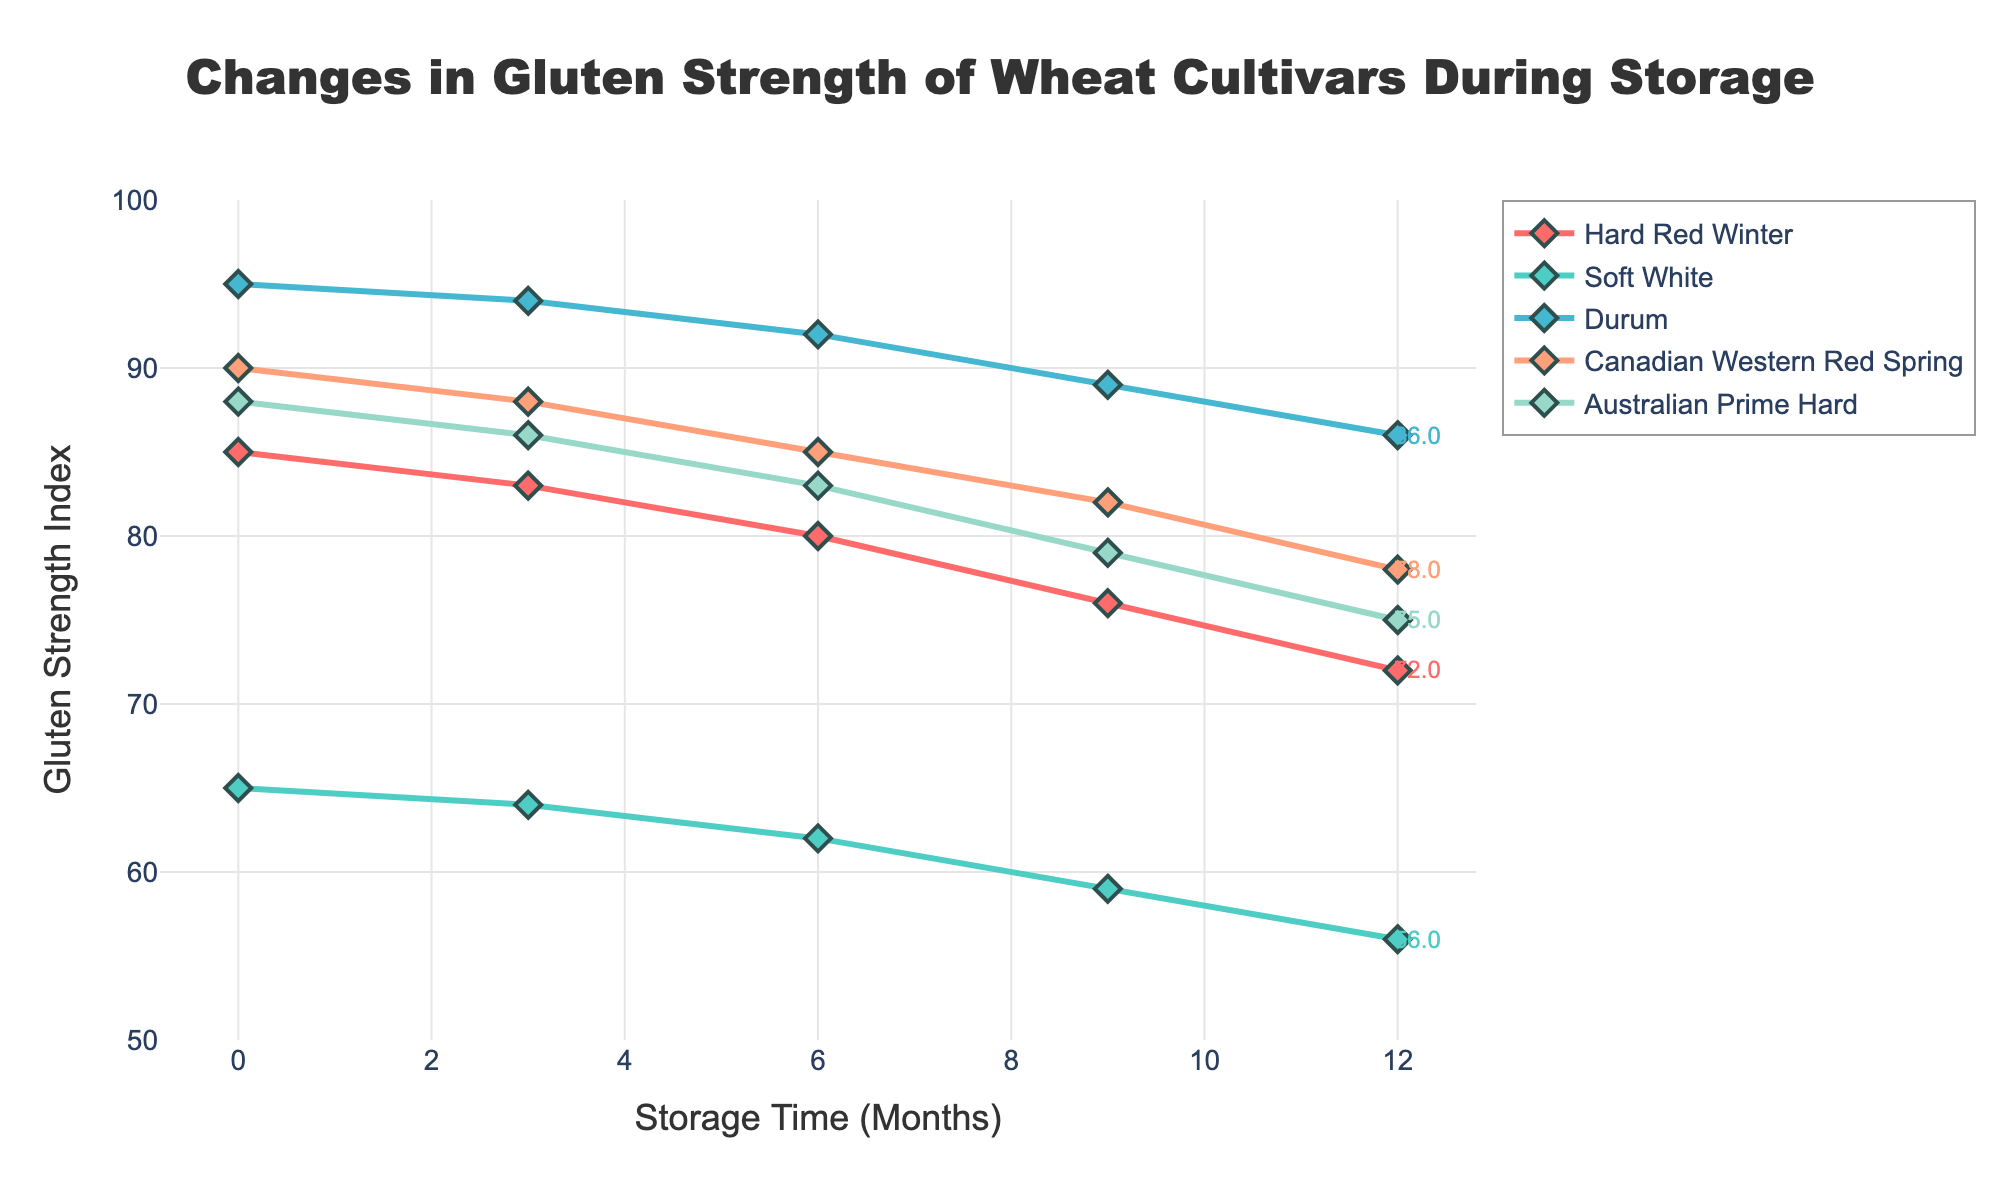Which wheat cultivar has the highest gluten strength after 6 months of storage? Look at the gluten strength values after 6 months for all cultivars. Compare the values to determine which one is the highest. Durum has a gluten strength index of 92, which is the highest.
Answer: Durum Which wheat cultivar shows the largest decrease in gluten strength from the beginning to 12 months of storage? Calculate the decrease for each cultivar from month 0 to month 12 and compare. Hard Red Winter shows the largest decrease from 85 to 72 which is a decrease of 13.
Answer: Hard Red Winter What is the average gluten strength of Soft White from 0 to 12 months? Sum the gluten strength values for Soft White at months 0, 3, 6, 9, and 12 and then divide by 5. The values are 65, 64, 62, 59, and 56. Sum is 65 + 64 + 62 + 59 + 56 = 306. Average is 306 / 5 = 61.2
Answer: 61.2 Which wheat cultivar retains more than 80% of its original gluten strength after 12 months? Calculate 80% of the initial gluten strength for each cultivar and then check if their 12-month value is above this threshold. Only Durum retains more than 80% of its original strength (80% of 95 is 76, and it retains 86).
Answer: Durum If one were to select a wheat cultivar that minimizes the loss in gluten strength, which one would it be? Measure the change in gluten strength from 0 to 12 months for each cultivar and find the one with the smallest decrease. Calculate the decrease for all cultivars. Durum drops from 95 to 86, a decrease of 9, which is the smallest.
Answer: Durum Between which two storage periods does Australian Prime Hard show the greatest drop in gluten strength? Determine the drop between each consecutive period for Australian Prime Hard and find the maximum. Drops are: 88 to 86 (2), 86 to 83 (3), 83 to 79 (4), and 79 to 75 (4). The greatest drop is 4 between 6 and 9 months, and 9 and 12 months.
Answer: 6 and 9 months, 9 and 12 months (equal) Compare the gluten strength of Hard Red Winter and Canadian Western Red Spring at 6 months. Which one is stronger? Look at the gluten strength index at 6 months for both cultivars. Hard Red Winter is at 80 and Canadian Western Red Spring is at 85. Canadian Western Red Spring is stronger.
Answer: Canadian Western Red Spring What is the difference in gluten strength between Durum and Soft White at the start? Check the gluten strength index at month 0 for both cultivars. Durum is at 95 and Soft White is at 65. The difference is 95 - 65 = 30.
Answer: 30 After 9 months, which cultivar has a gluten strength closest to 80? Check the gluten strength values at month 9 for all cultivars and identify the one closest to 80. Hard Red Winter is at 76, Soft White is at 59, Durum is at 89, Canadian Western Red Spring is at 82, and Australian Prime Hard is at 79. Australian Prime Hard is the closest at 79.
Answer: Australian Prime Hard 